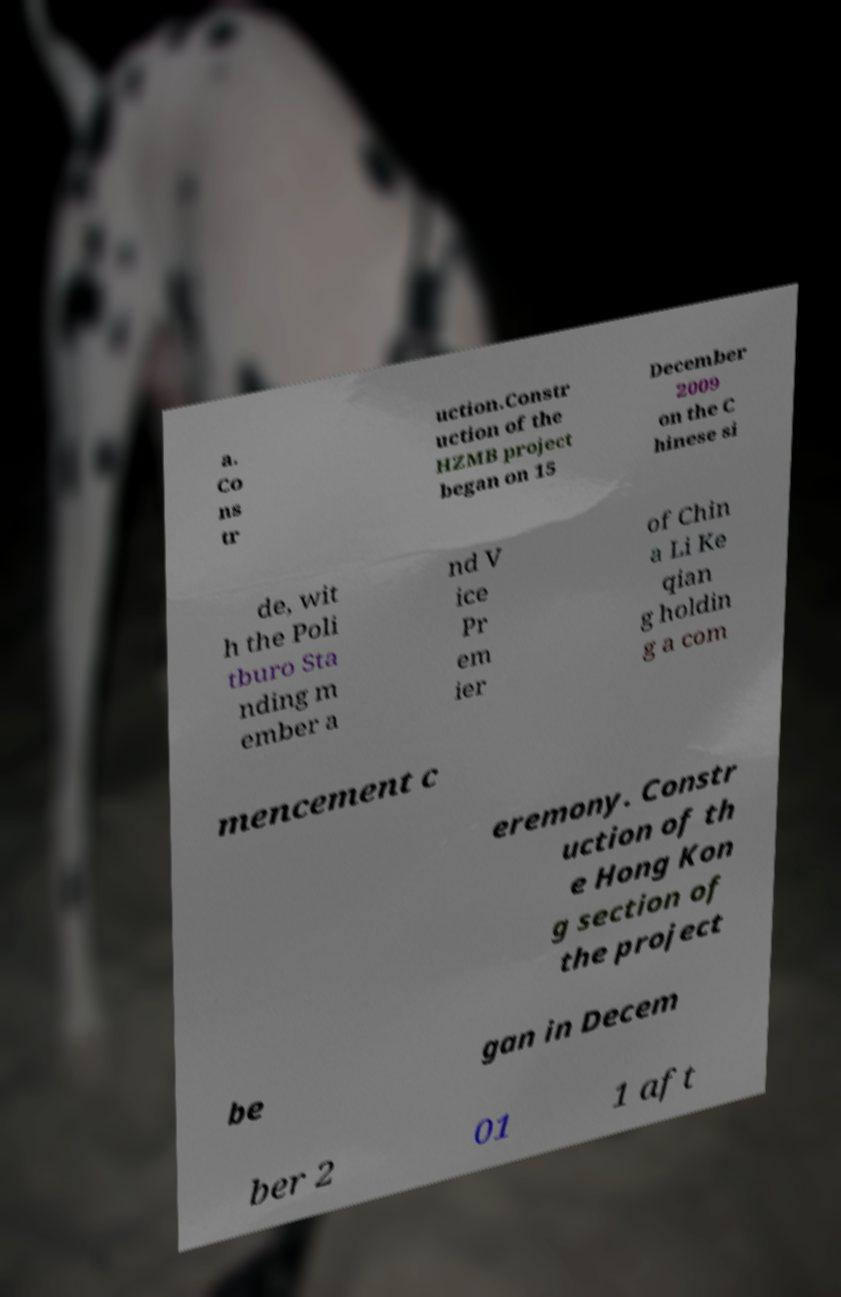Please identify and transcribe the text found in this image. a. Co ns tr uction.Constr uction of the HZMB project began on 15 December 2009 on the C hinese si de, wit h the Poli tburo Sta nding m ember a nd V ice Pr em ier of Chin a Li Ke qian g holdin g a com mencement c eremony. Constr uction of th e Hong Kon g section of the project be gan in Decem ber 2 01 1 aft 